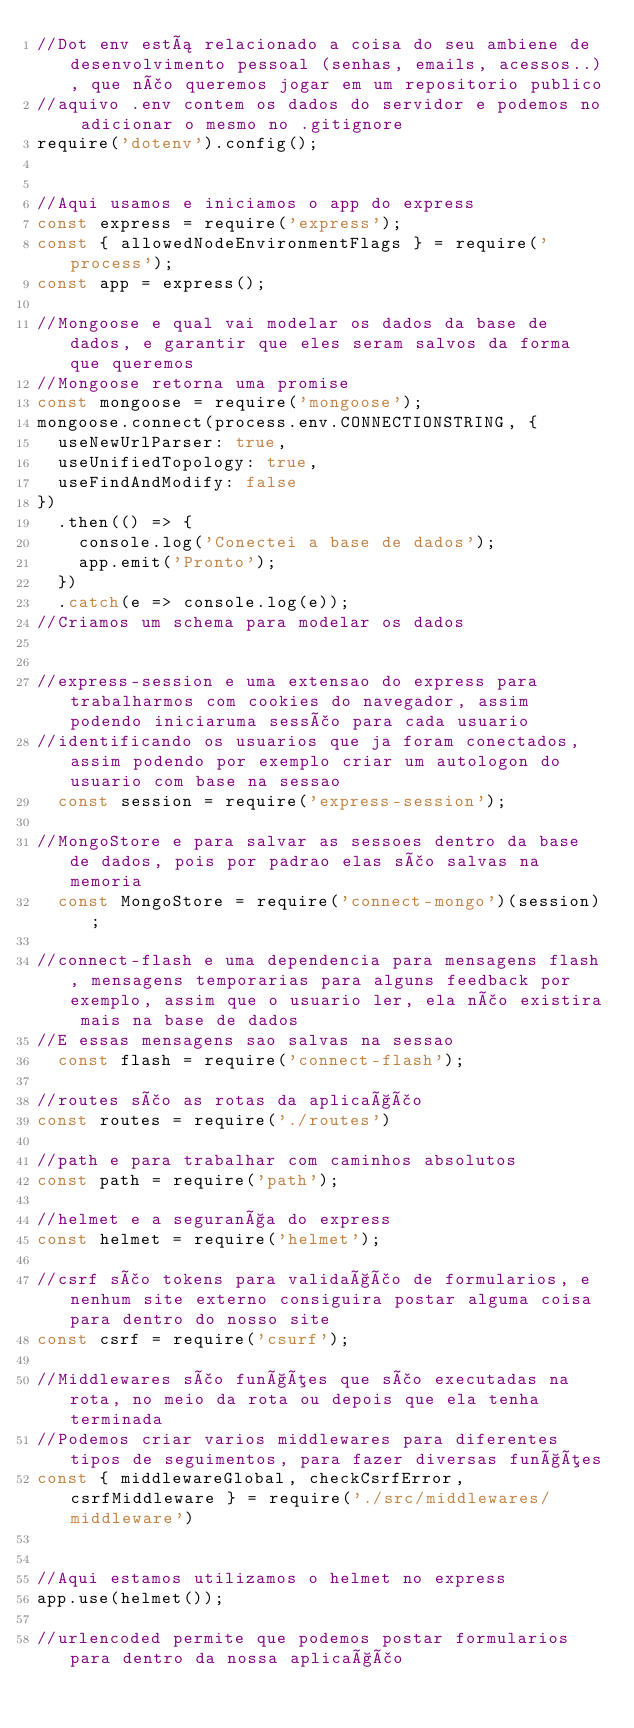<code> <loc_0><loc_0><loc_500><loc_500><_JavaScript_>//Dot env está relacionado a coisa do seu ambiene de desenvolvimento pessoal (senhas, emails, acessos..), que não queremos jogar em um repositorio publico
//aquivo .env contem os dados do servidor e podemos no adicionar o mesmo no .gitignore
require('dotenv').config();


//Aqui usamos e iniciamos o app do express
const express = require('express');
const { allowedNodeEnvironmentFlags } = require('process');
const app = express();

//Mongoose e qual vai modelar os dados da base de dados, e garantir que eles seram salvos da forma que queremos
//Mongoose retorna uma promise
const mongoose = require('mongoose');
mongoose.connect(process.env.CONNECTIONSTRING, { 
  useNewUrlParser: true, 
  useUnifiedTopology: true, 
  useFindAndModify: false 
})
  .then(() => {
    console.log('Conectei a base de dados');
    app.emit('Pronto');
  })
  .catch(e => console.log(e));
//Criamos um schema para modelar os dados


//express-session e uma extensao do express para trabalharmos com cookies do navegador, assim podendo iniciaruma sessão para cada usuario
//identificando os usuarios que ja foram conectados, assim podendo por exemplo criar um autologon do usuario com base na sessao
  const session = require('express-session');

//MongoStore e para salvar as sessoes dentro da base de dados, pois por padrao elas são salvas na memoria
  const MongoStore = require('connect-mongo')(session);

//connect-flash e uma dependencia para mensagens flash, mensagens temporarias para alguns feedback por exemplo, assim que o usuario ler, ela não existira mais na base de dados
//E essas mensagens sao salvas na sessao
  const flash = require('connect-flash');

//routes são as rotas da aplicação
const routes = require('./routes')

//path e para trabalhar com caminhos absolutos
const path = require('path');

//helmet e a segurança do express
const helmet = require('helmet');

//csrf são tokens para validação de formularios, e nenhum site externo consiguira postar alguma coisa para dentro do nosso site
const csrf = require('csurf');

//Middlewares são funções que são executadas na rota, no meio da rota ou depois que ela tenha terminada
//Podemos criar varios middlewares para diferentes tipos de seguimentos, para fazer diversas funções
const { middlewareGlobal, checkCsrfError, csrfMiddleware } = require('./src/middlewares/middleware')


//Aqui estamos utilizamos o helmet no express
app.use(helmet());

//urlencoded permite que podemos postar formularios para dentro da nossa aplicação</code> 